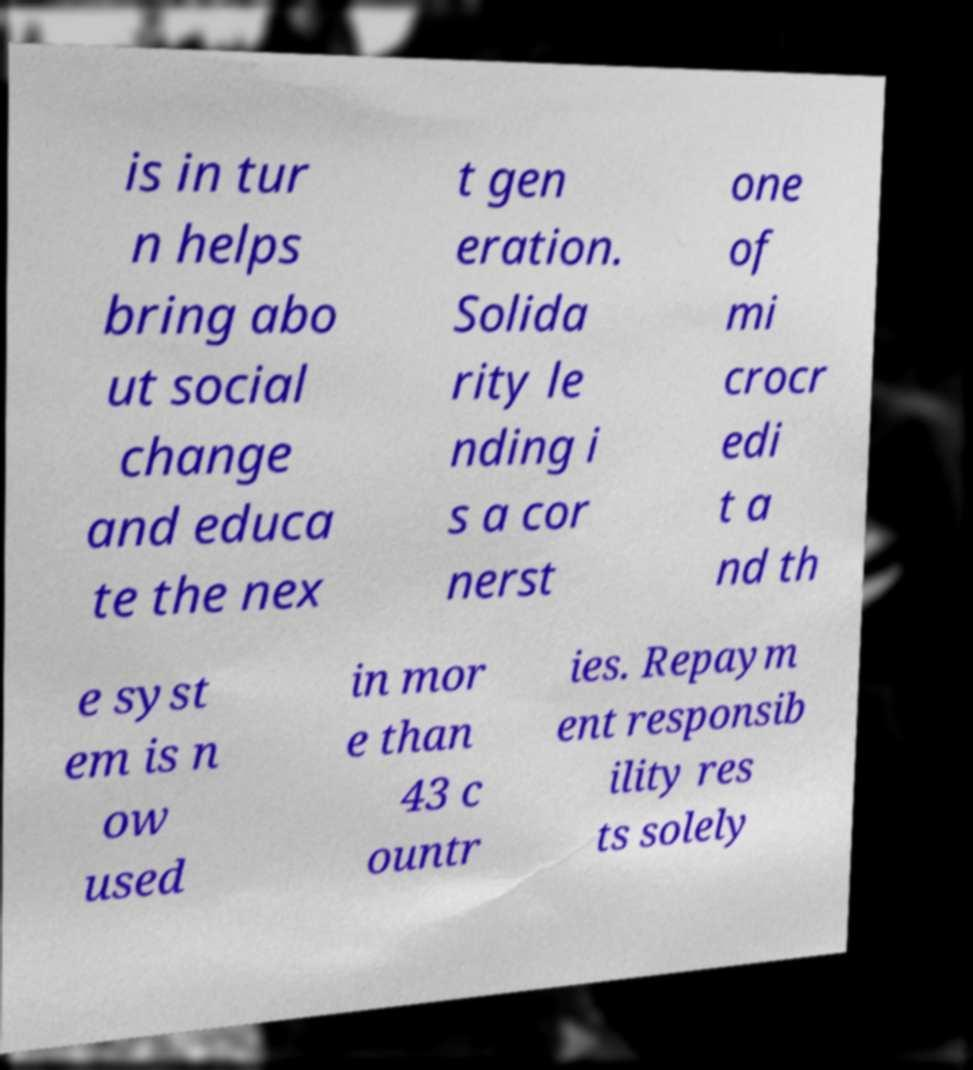There's text embedded in this image that I need extracted. Can you transcribe it verbatim? is in tur n helps bring abo ut social change and educa te the nex t gen eration. Solida rity le nding i s a cor nerst one of mi crocr edi t a nd th e syst em is n ow used in mor e than 43 c ountr ies. Repaym ent responsib ility res ts solely 